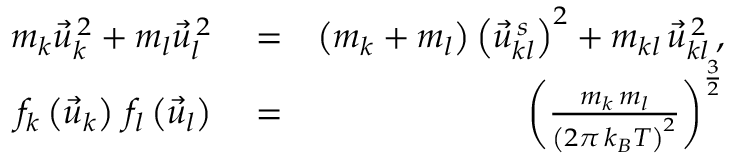Convert formula to latex. <formula><loc_0><loc_0><loc_500><loc_500>\begin{array} { r l r } { m _ { k } \vec { u } _ { k } ^ { \, 2 } + m _ { l } \vec { u } _ { l } ^ { \, 2 } } & = } & { \left ( m _ { k } + m _ { l } \right ) \left ( \vec { u } _ { k l } ^ { \, s } \right ) ^ { 2 } + m _ { k l } \, \vec { u } _ { k l } ^ { \, 2 } \, , } \\ { f _ { k } \left ( \vec { u } _ { k } \right ) \, f _ { l } \left ( \vec { u } _ { l } \right ) } & = } & { \left ( \frac { m _ { k } \, m _ { l } } { \left ( 2 \pi \, k _ { B } T \right ) ^ { 2 } } \right ) ^ { \frac { 3 } { 2 } } } \end{array}</formula> 